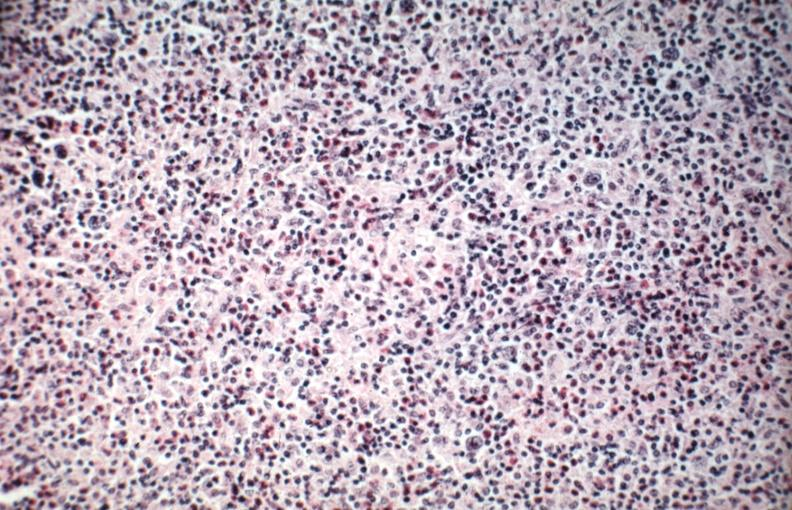what is present?
Answer the question using a single word or phrase. Lymph node 